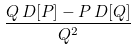Convert formula to latex. <formula><loc_0><loc_0><loc_500><loc_500>\frac { Q \, D [ P ] - P \, D [ Q ] } { Q ^ { 2 } }</formula> 